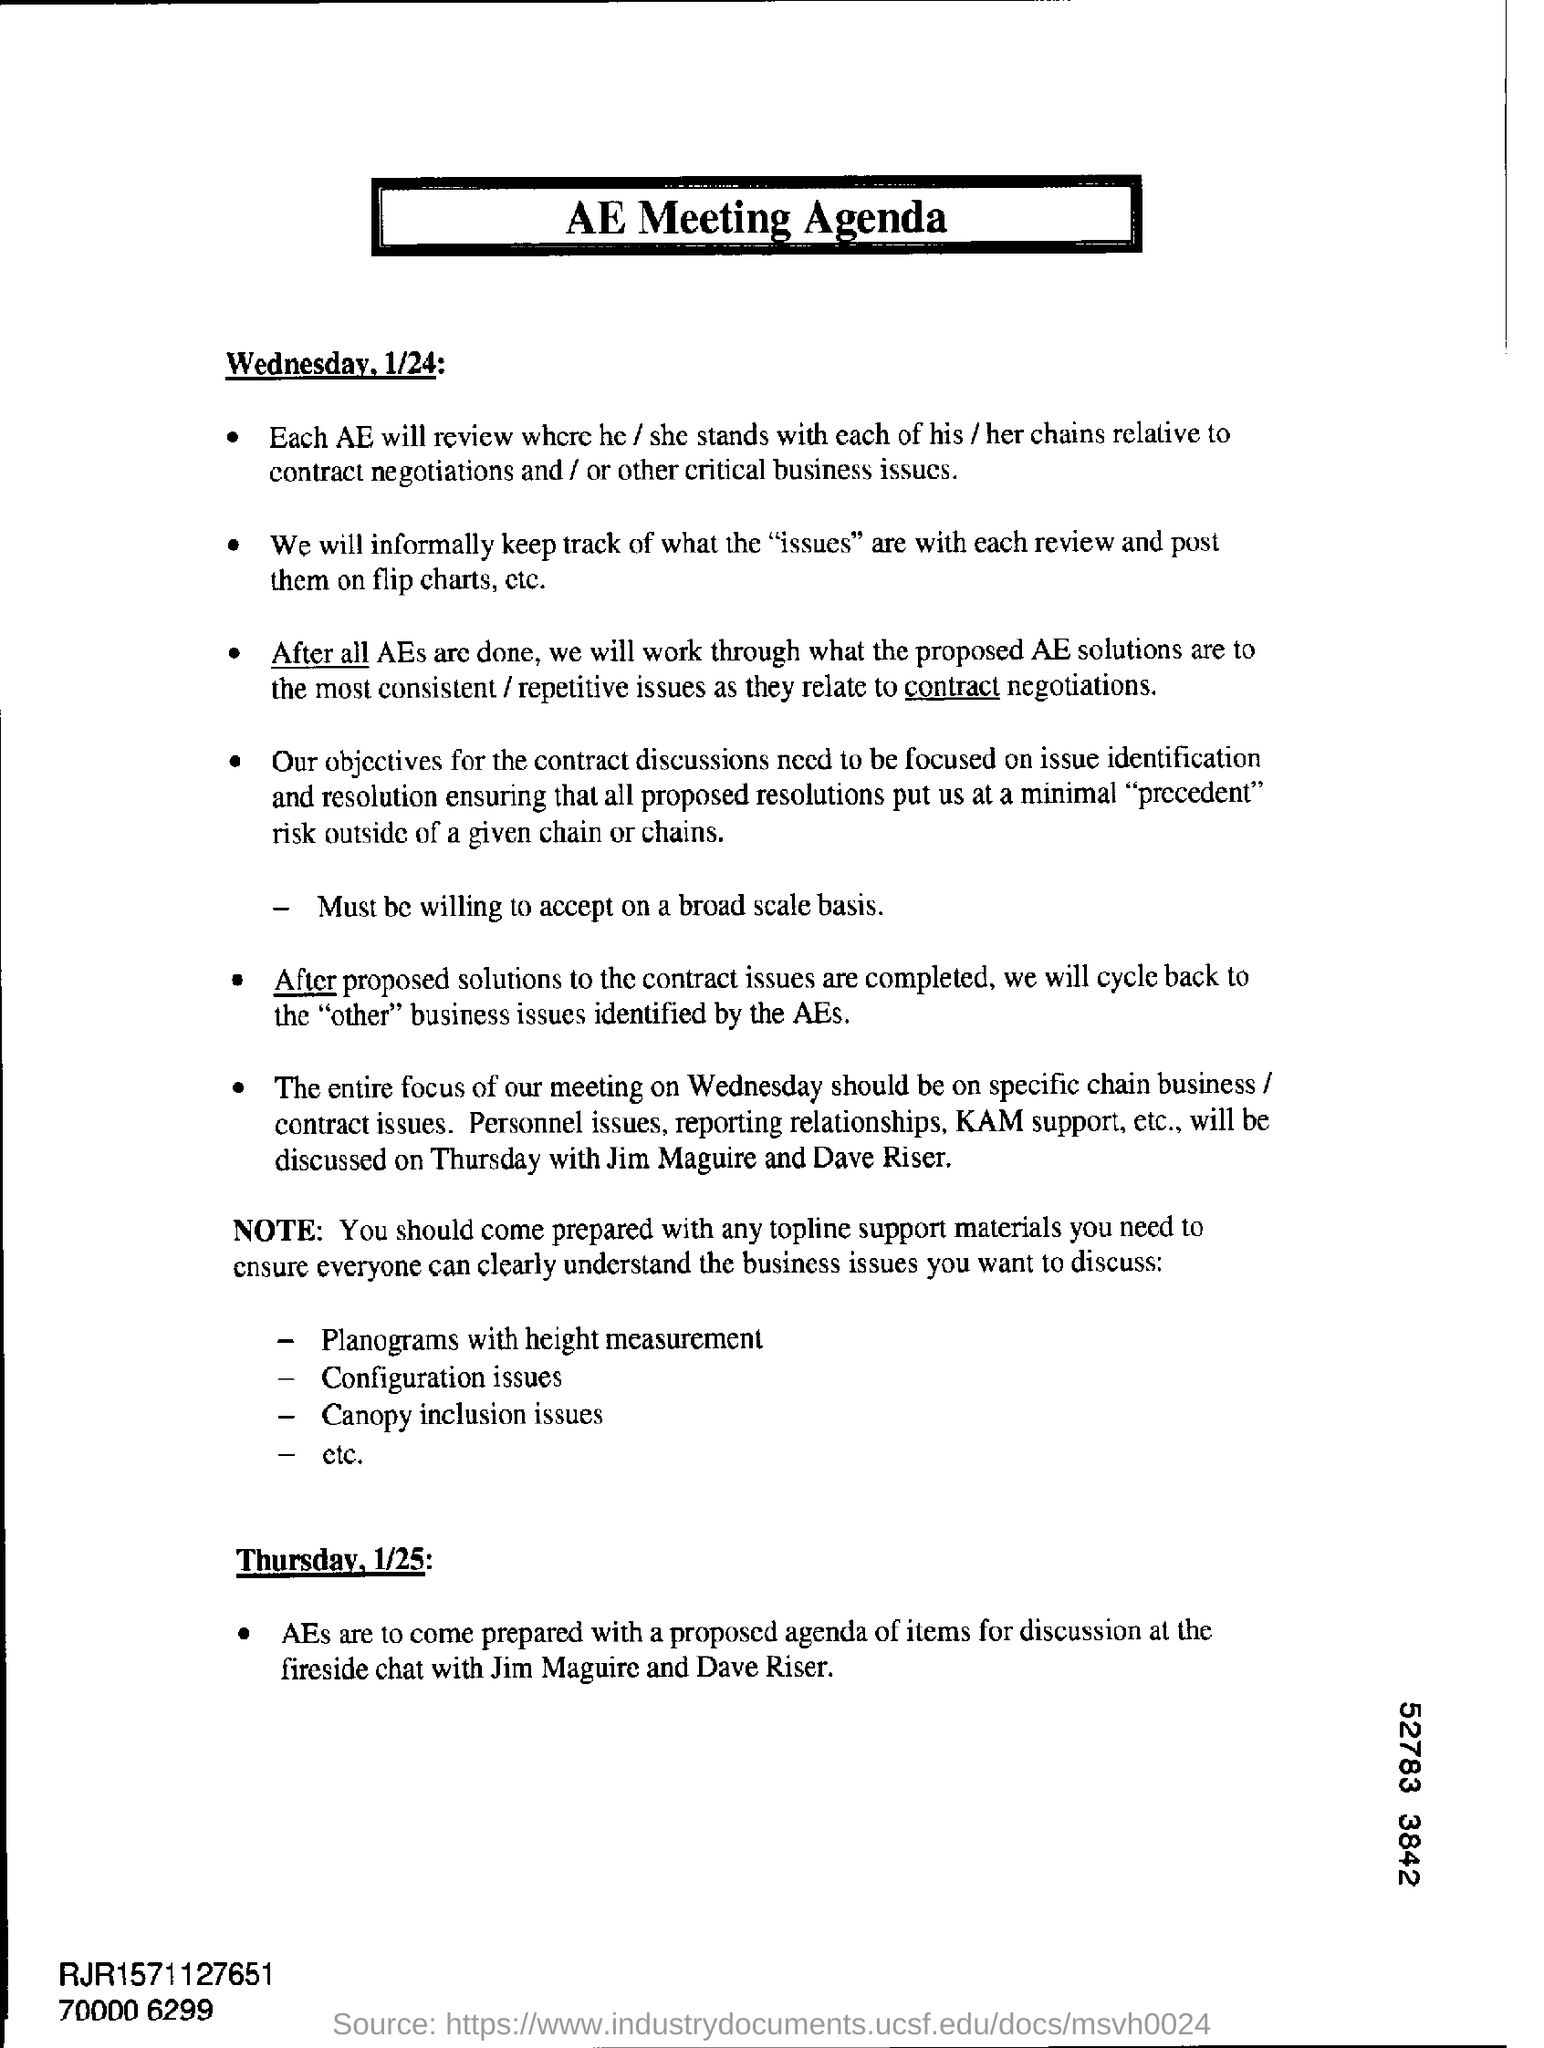What is digit shown at the bottom right corner?
Give a very brief answer. 52783 3842. 